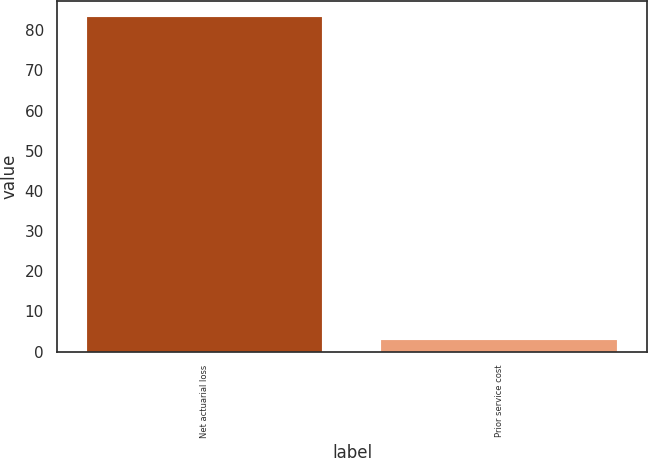<chart> <loc_0><loc_0><loc_500><loc_500><bar_chart><fcel>Net actuarial loss<fcel>Prior service cost<nl><fcel>83.2<fcel>2.8<nl></chart> 